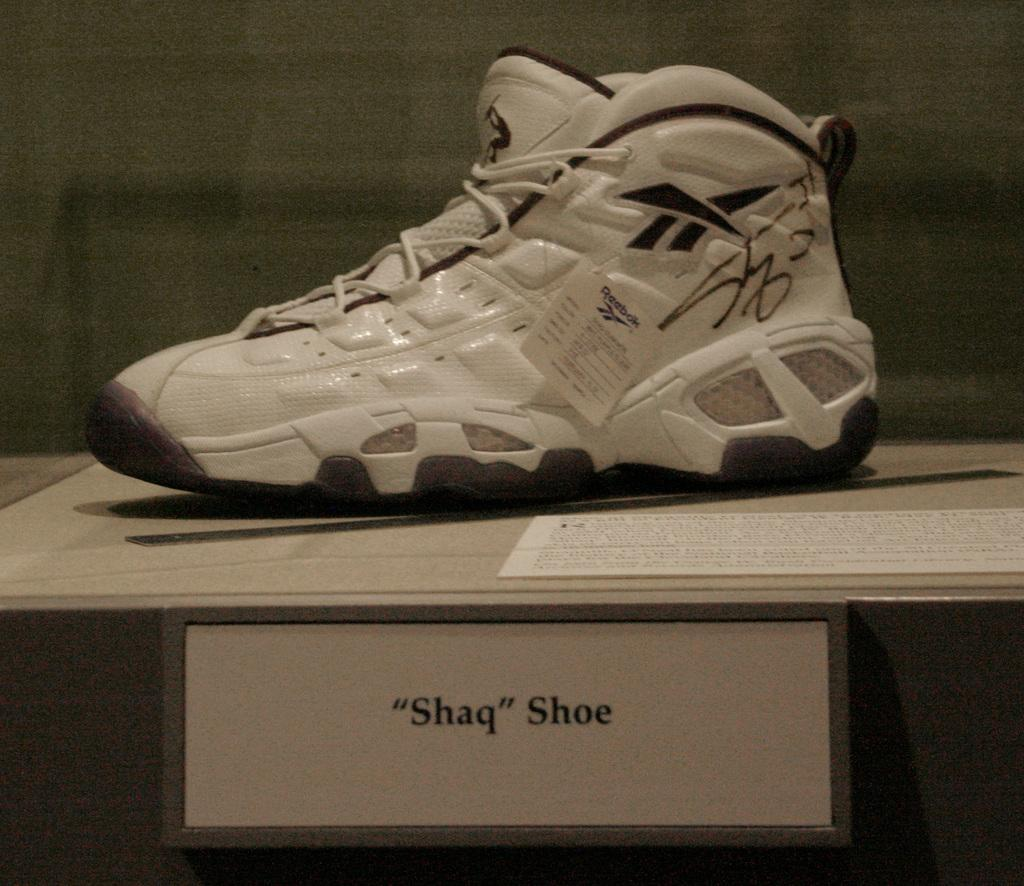What object can be seen on the table in the image? There is a shoe and a paper on the table in the image. What is the purpose of the paper beside the shoe? The purpose of the paper is not specified in the image. What is the board with text used for in the image? The board with text is on the table, but its purpose is not specified in the image. What is visible in the background of the image? There is a wall in the background of the image. How many grapes are on the table in the image? There are no grapes present in the image. What type of guide is shown assisting the person in the image? There is no guide or person present in the image. 